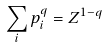Convert formula to latex. <formula><loc_0><loc_0><loc_500><loc_500>\sum _ { i } p _ { i } ^ { q } = Z ^ { 1 - q }</formula> 